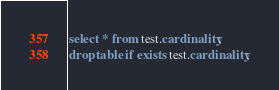Convert code to text. <code><loc_0><loc_0><loc_500><loc_500><_SQL_>select * from test.cardinality;
drop table if exists test.cardinality;
</code> 